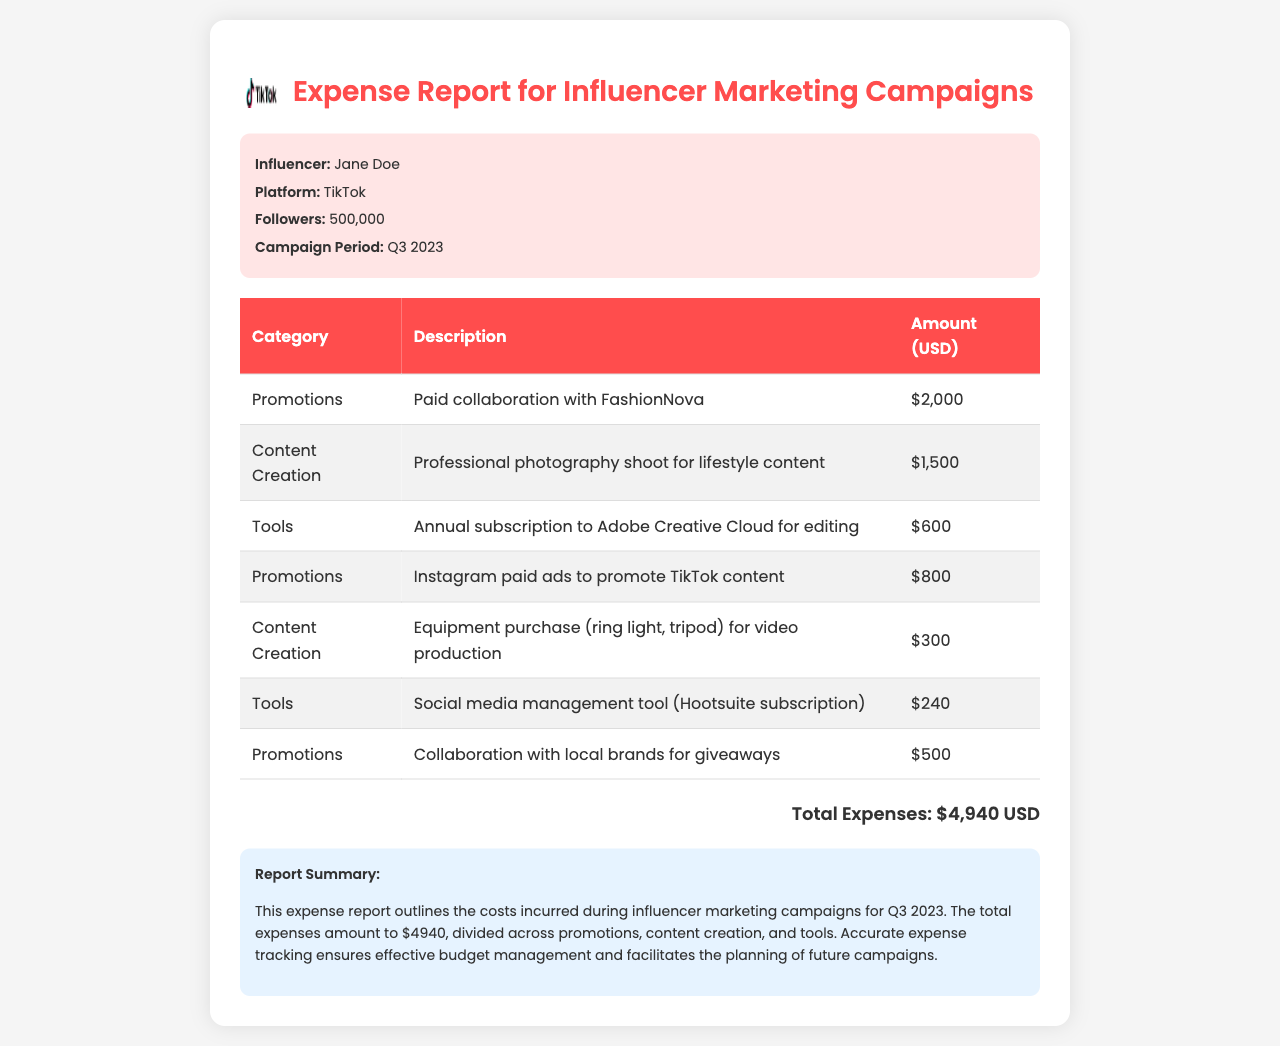what is the influencer's name? The document mentions the influencer's name as Jane Doe.
Answer: Jane Doe what is the campaign period? The campaign period is specified as Q3 2023 in the document.
Answer: Q3 2023 what is the total amount spent on promotions? The total for all promotions listed is $2,000 + $800 + $500, which equals $3,300.
Answer: $3,300 how much did the professional photography shoot cost? The document states that the professional photography shoot for lifestyle content cost $1,500.
Answer: $1,500 what is the total expenses amount? The total expenses calculated in the document is $4,940.
Answer: $4,940 what tool subscription costs $600? The document mentions the annual subscription to Adobe Creative Cloud for editing costing $600.
Answer: Adobe Creative Cloud how much was spent on equipment purchase? The document states that the equipment purchase for video production cost $300.
Answer: $300 which social media management tool is mentioned? The document indicates that Hootsuite subscription was used as the social media management tool.
Answer: Hootsuite how many followers does the influencer have? The document specifies that the influencer has 500,000 followers.
Answer: 500,000 